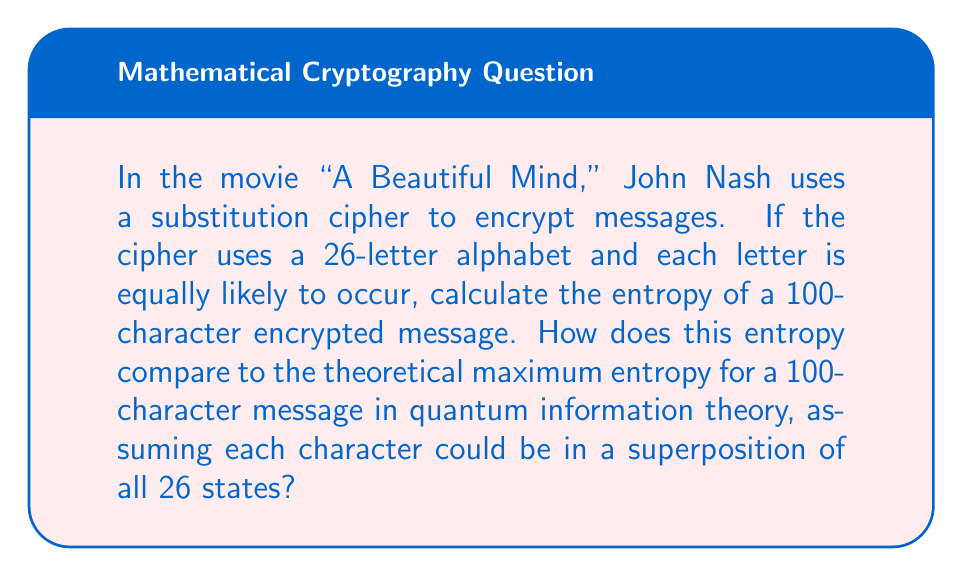Teach me how to tackle this problem. Let's approach this step-by-step:

1) For a classical substitution cipher with 26 equally likely letters:
   The probability of each letter, $p = \frac{1}{26}$

2) The entropy of a single character is given by Shannon's formula:
   $$H = -\sum_{i=1}^{26} p_i \log_2(p_i) = -26 \cdot \frac{1}{26} \log_2(\frac{1}{26}) = \log_2(26) \approx 4.7004 \text{ bits}$$

3) For a 100-character message, the total entropy is:
   $$H_{total} = 100 \cdot \log_2(26) \approx 470.0400 \text{ bits}$$

4) In quantum information theory, each character could be in a superposition of all 26 states. The maximum entropy for such a quantum system is given by the logarithm of the dimension of the Hilbert space:
   $$H_{quantum} = \log_2(26^{100}) = 100 \cdot \log_2(26) \approx 470.0400 \text{ bits}$$

5) Interestingly, the classical entropy of the substitution cipher equals the maximum quantum entropy in this case. This is because the substitution cipher already maximizes the classical entropy by making all outcomes equally likely.

6) In quantum mechanics, this equality between classical and quantum entropy occurs when the system is in a maximally mixed state, which is analogous to our scenario where all classical outcomes are equally probable.
Answer: 470.0400 bits; equal to the quantum maximum 